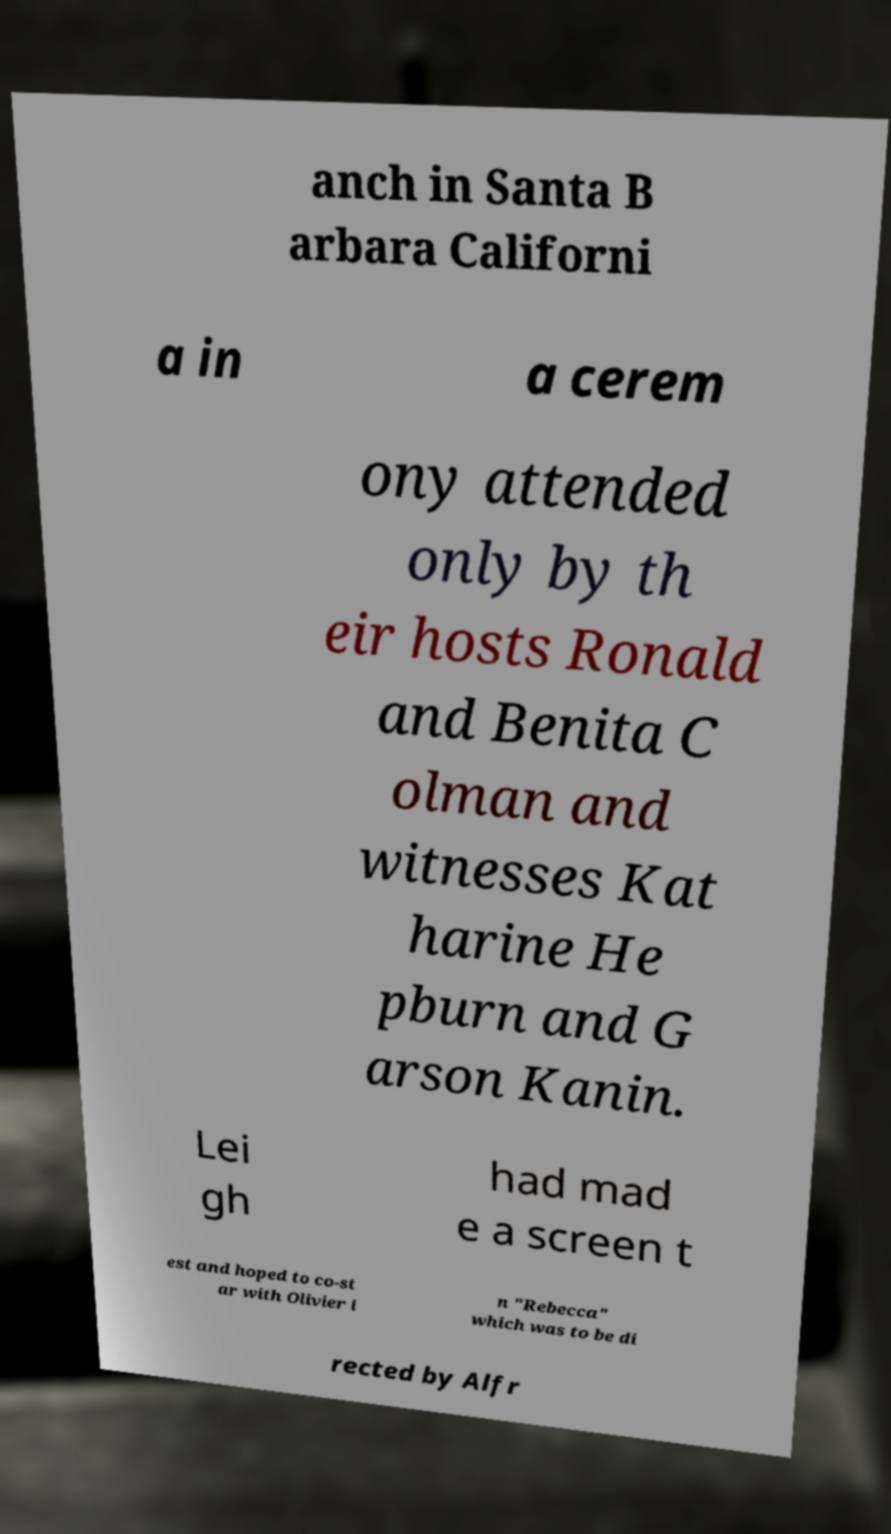There's text embedded in this image that I need extracted. Can you transcribe it verbatim? anch in Santa B arbara Californi a in a cerem ony attended only by th eir hosts Ronald and Benita C olman and witnesses Kat harine He pburn and G arson Kanin. Lei gh had mad e a screen t est and hoped to co-st ar with Olivier i n "Rebecca" which was to be di rected by Alfr 